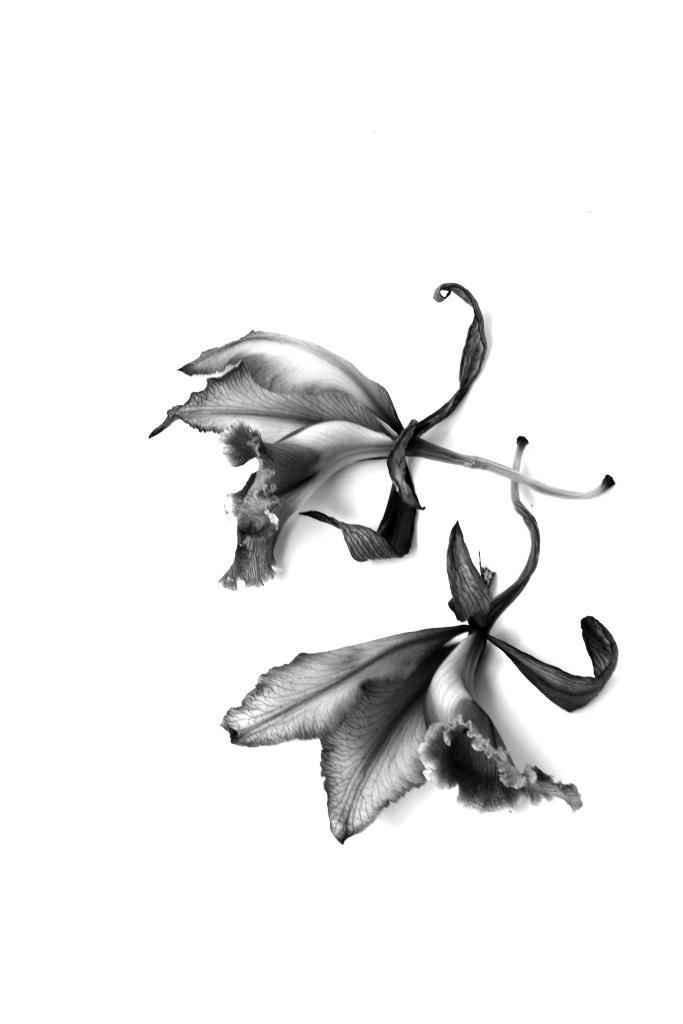What is the color scheme of the image? The image is black and white. How many flowers can be seen in the image? There are two flowers in the image. What parts of the flowers are visible? The flowers have leaves and stems. What type of joke is being told by the cows in the image? There are no cows present in the image, so no joke can be observed. 